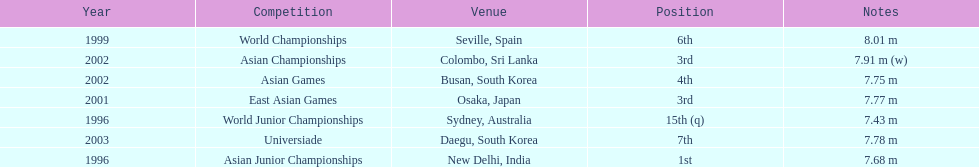Which competition did this person compete in immediately before the east asian games in 2001? World Championships. 